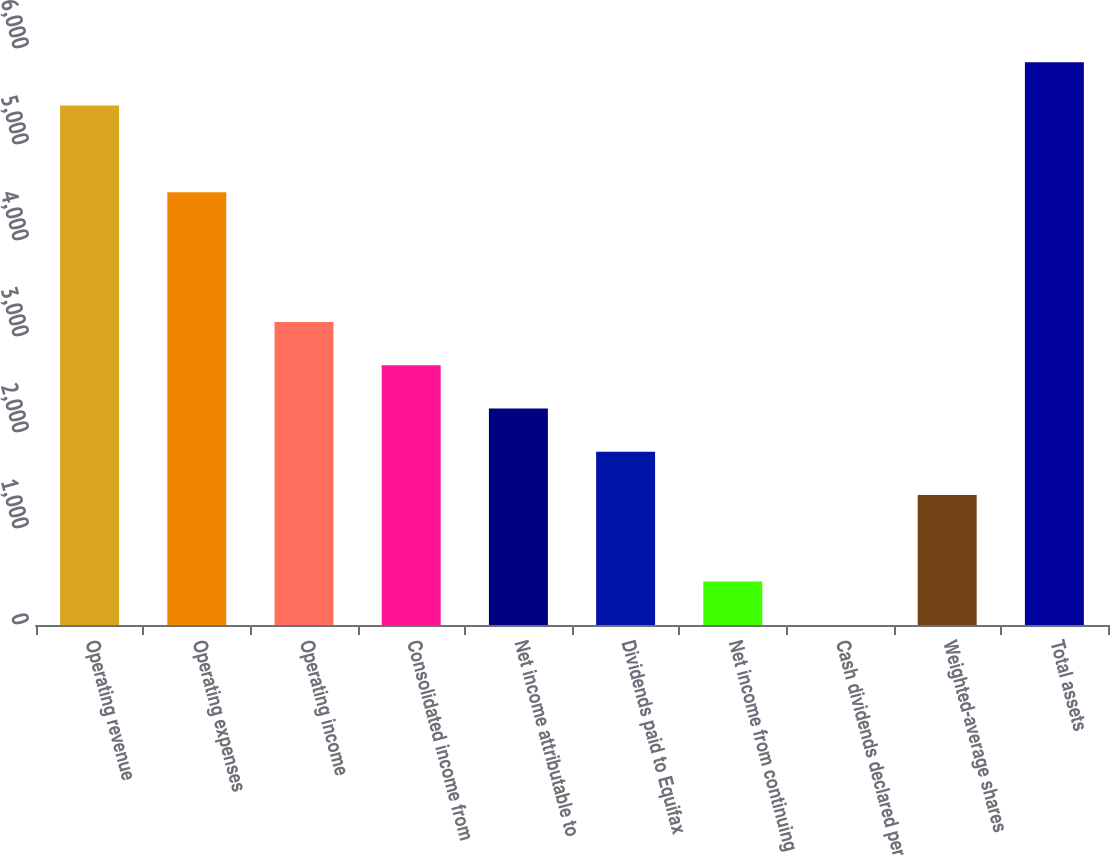Convert chart to OTSL. <chart><loc_0><loc_0><loc_500><loc_500><bar_chart><fcel>Operating revenue<fcel>Operating expenses<fcel>Operating income<fcel>Consolidated income from<fcel>Net income attributable to<fcel>Dividends paid to Equifax<fcel>Net income from continuing<fcel>Cash dividends declared per<fcel>Weighted-average shares<fcel>Total assets<nl><fcel>5410.52<fcel>4508.96<fcel>3156.62<fcel>2705.84<fcel>2255.06<fcel>1804.28<fcel>451.94<fcel>1.16<fcel>1353.5<fcel>5861.3<nl></chart> 